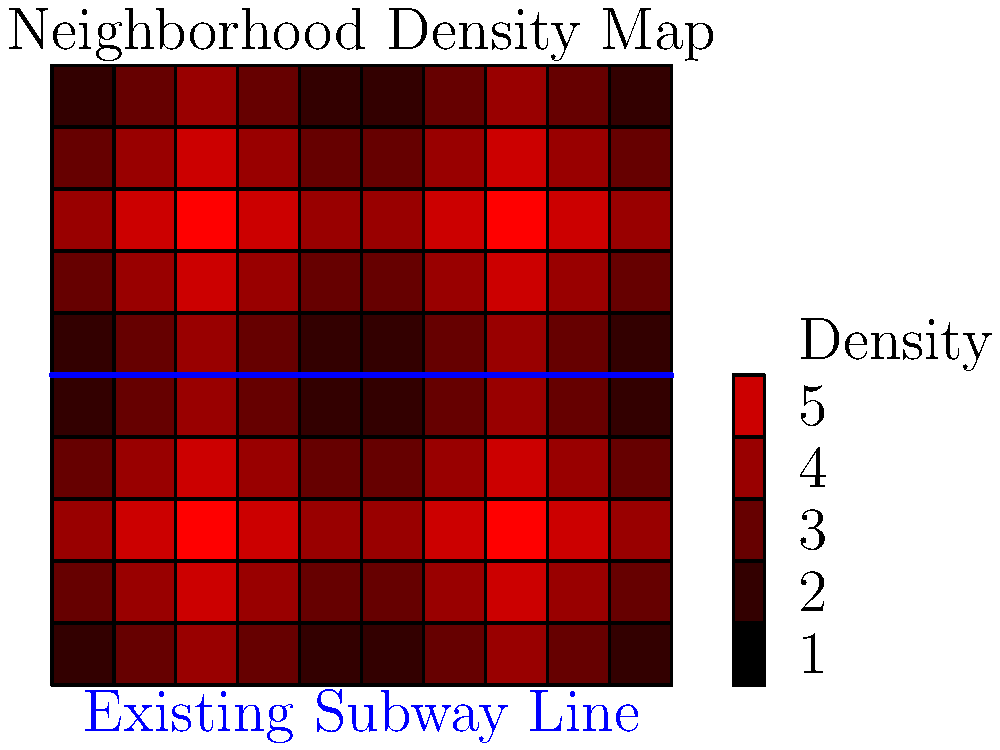Based on the neighborhood density map shown above, where would be the optimal location to add a new subway entrance to serve the highest number of residents? Assume the existing subway line runs horizontally through the center of the map. To determine the optimal location for a new subway entrance, we need to analyze the population density distribution on the map and consider the existing subway line. Let's break it down step-by-step:

1. Observe the density distribution:
   The map shows varying levels of population density, with darker red indicating higher density.

2. Identify high-density areas:
   There are two distinct high-density regions visible on the map, located in the upper-left and upper-right quadrants.

3. Consider the existing subway line:
   The blue line running horizontally through the center represents the existing subway line.

4. Evaluate accessibility:
   The lower half of the map is already well-served by the existing subway line. Therefore, we should focus on the upper half.

5. Compare the two high-density regions:
   Both high-density areas in the upper half have similar intensity. However, the upper-right quadrant is slightly closer to the existing line, which could make construction and connection easier.

6. Determine the optimal location:
   The best location for a new entrance would be at the center of the high-density area in the upper-right quadrant, approximately at coordinates (7, 7) on the grid.

7. Consider future expansion:
   This location also allows for potential future expansion to serve the upper-left high-density area if needed.

Therefore, the optimal location for a new subway entrance would be in the upper-right quadrant, centered in the high-density area, at approximately (7, 7) on the grid.
Answer: Upper-right quadrant, coordinates (7, 7) 